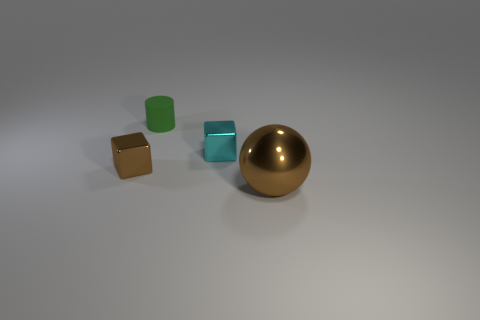There is a object right of the cyan metal thing; does it have the same color as the small cylinder?
Your response must be concise. No. Is the number of tiny green matte cylinders less than the number of big green blocks?
Make the answer very short. No. What number of other objects are there of the same color as the shiny sphere?
Your answer should be compact. 1. Does the brown object behind the large brown metal sphere have the same material as the cylinder?
Your answer should be compact. No. What material is the thing that is behind the tiny cyan shiny object?
Ensure brevity in your answer.  Rubber. There is a brown metal object that is on the left side of the brown ball right of the cyan cube; how big is it?
Your response must be concise. Small. Are there any small green cylinders that have the same material as the small brown block?
Your response must be concise. No. There is a small shiny thing that is on the left side of the block behind the brown metal object that is behind the big brown object; what shape is it?
Your response must be concise. Cube. There is a shiny ball in front of the small brown block; is its color the same as the metal block that is left of the green rubber object?
Your answer should be very brief. Yes. Are there any other things that are the same size as the cyan metal block?
Give a very brief answer. Yes. 